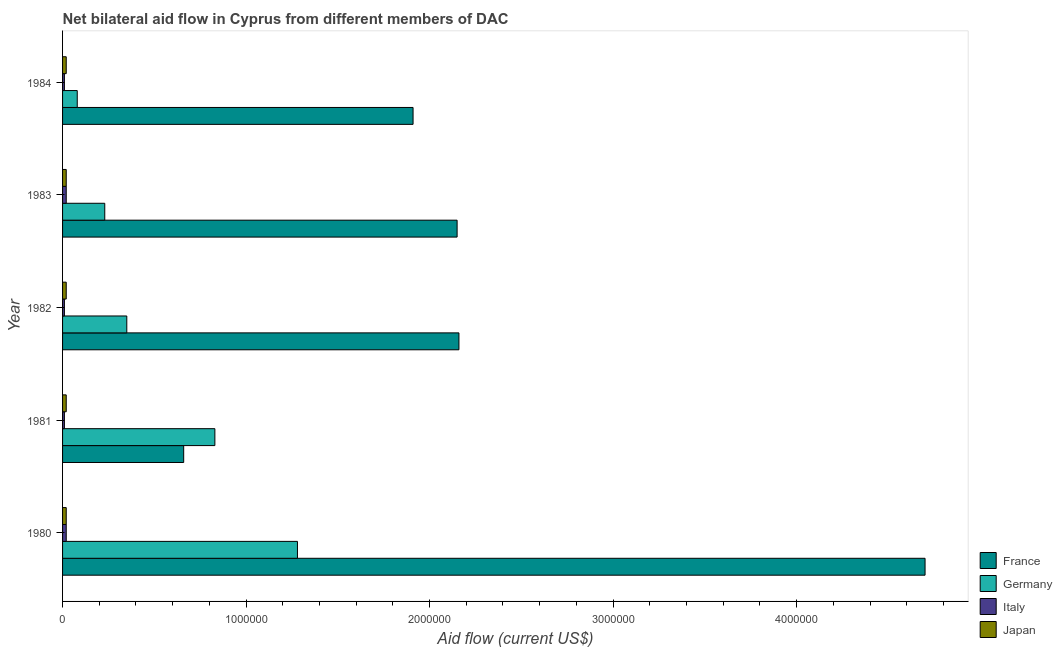Are the number of bars per tick equal to the number of legend labels?
Make the answer very short. Yes. Are the number of bars on each tick of the Y-axis equal?
Your answer should be compact. Yes. How many bars are there on the 3rd tick from the top?
Give a very brief answer. 4. How many bars are there on the 4th tick from the bottom?
Ensure brevity in your answer.  4. What is the label of the 5th group of bars from the top?
Offer a very short reply. 1980. In how many cases, is the number of bars for a given year not equal to the number of legend labels?
Give a very brief answer. 0. What is the amount of aid given by italy in 1982?
Ensure brevity in your answer.  10000. Across all years, what is the maximum amount of aid given by japan?
Make the answer very short. 2.00e+04. Across all years, what is the minimum amount of aid given by italy?
Provide a succinct answer. 10000. In which year was the amount of aid given by japan minimum?
Keep it short and to the point. 1980. What is the total amount of aid given by france in the graph?
Provide a short and direct response. 1.16e+07. What is the difference between the amount of aid given by germany in 1981 and that in 1983?
Offer a very short reply. 6.00e+05. What is the difference between the amount of aid given by france in 1981 and the amount of aid given by italy in 1983?
Provide a short and direct response. 6.40e+05. What is the average amount of aid given by italy per year?
Offer a terse response. 1.40e+04. In the year 1984, what is the difference between the amount of aid given by france and amount of aid given by japan?
Provide a short and direct response. 1.89e+06. In how many years, is the amount of aid given by germany greater than 4200000 US$?
Your response must be concise. 0. Is the amount of aid given by japan in 1981 less than that in 1983?
Make the answer very short. No. Is the difference between the amount of aid given by italy in 1980 and 1983 greater than the difference between the amount of aid given by japan in 1980 and 1983?
Offer a terse response. No. What is the difference between the highest and the second highest amount of aid given by france?
Make the answer very short. 2.54e+06. What is the difference between the highest and the lowest amount of aid given by japan?
Make the answer very short. 0. What does the 4th bar from the bottom in 1982 represents?
Your answer should be compact. Japan. Are all the bars in the graph horizontal?
Offer a terse response. Yes. What is the difference between two consecutive major ticks on the X-axis?
Provide a short and direct response. 1.00e+06. Does the graph contain any zero values?
Offer a very short reply. No. Does the graph contain grids?
Ensure brevity in your answer.  No. What is the title of the graph?
Your response must be concise. Net bilateral aid flow in Cyprus from different members of DAC. Does "Revenue mobilization" appear as one of the legend labels in the graph?
Offer a very short reply. No. What is the label or title of the X-axis?
Offer a terse response. Aid flow (current US$). What is the Aid flow (current US$) of France in 1980?
Your answer should be compact. 4.70e+06. What is the Aid flow (current US$) of Germany in 1980?
Give a very brief answer. 1.28e+06. What is the Aid flow (current US$) in Italy in 1980?
Keep it short and to the point. 2.00e+04. What is the Aid flow (current US$) of France in 1981?
Your answer should be compact. 6.60e+05. What is the Aid flow (current US$) in Germany in 1981?
Ensure brevity in your answer.  8.30e+05. What is the Aid flow (current US$) of Italy in 1981?
Give a very brief answer. 10000. What is the Aid flow (current US$) in France in 1982?
Your answer should be compact. 2.16e+06. What is the Aid flow (current US$) of Italy in 1982?
Ensure brevity in your answer.  10000. What is the Aid flow (current US$) of Japan in 1982?
Your response must be concise. 2.00e+04. What is the Aid flow (current US$) in France in 1983?
Offer a very short reply. 2.15e+06. What is the Aid flow (current US$) in Germany in 1983?
Make the answer very short. 2.30e+05. What is the Aid flow (current US$) in France in 1984?
Your response must be concise. 1.91e+06. Across all years, what is the maximum Aid flow (current US$) of France?
Your answer should be very brief. 4.70e+06. Across all years, what is the maximum Aid flow (current US$) of Germany?
Your answer should be compact. 1.28e+06. Across all years, what is the maximum Aid flow (current US$) of Italy?
Make the answer very short. 2.00e+04. Across all years, what is the minimum Aid flow (current US$) of France?
Your answer should be compact. 6.60e+05. Across all years, what is the minimum Aid flow (current US$) of Italy?
Provide a succinct answer. 10000. Across all years, what is the minimum Aid flow (current US$) of Japan?
Your answer should be compact. 2.00e+04. What is the total Aid flow (current US$) of France in the graph?
Your answer should be compact. 1.16e+07. What is the total Aid flow (current US$) of Germany in the graph?
Your answer should be very brief. 2.77e+06. What is the difference between the Aid flow (current US$) in France in 1980 and that in 1981?
Provide a short and direct response. 4.04e+06. What is the difference between the Aid flow (current US$) of Germany in 1980 and that in 1981?
Your response must be concise. 4.50e+05. What is the difference between the Aid flow (current US$) in France in 1980 and that in 1982?
Keep it short and to the point. 2.54e+06. What is the difference between the Aid flow (current US$) in Germany in 1980 and that in 1982?
Make the answer very short. 9.30e+05. What is the difference between the Aid flow (current US$) in Italy in 1980 and that in 1982?
Make the answer very short. 10000. What is the difference between the Aid flow (current US$) in France in 1980 and that in 1983?
Your answer should be very brief. 2.55e+06. What is the difference between the Aid flow (current US$) of Germany in 1980 and that in 1983?
Offer a terse response. 1.05e+06. What is the difference between the Aid flow (current US$) in Japan in 1980 and that in 1983?
Offer a very short reply. 0. What is the difference between the Aid flow (current US$) in France in 1980 and that in 1984?
Provide a succinct answer. 2.79e+06. What is the difference between the Aid flow (current US$) of Germany in 1980 and that in 1984?
Make the answer very short. 1.20e+06. What is the difference between the Aid flow (current US$) in Italy in 1980 and that in 1984?
Your answer should be compact. 10000. What is the difference between the Aid flow (current US$) of France in 1981 and that in 1982?
Your response must be concise. -1.50e+06. What is the difference between the Aid flow (current US$) in Germany in 1981 and that in 1982?
Provide a short and direct response. 4.80e+05. What is the difference between the Aid flow (current US$) of Italy in 1981 and that in 1982?
Provide a succinct answer. 0. What is the difference between the Aid flow (current US$) of France in 1981 and that in 1983?
Offer a terse response. -1.49e+06. What is the difference between the Aid flow (current US$) of Germany in 1981 and that in 1983?
Make the answer very short. 6.00e+05. What is the difference between the Aid flow (current US$) of Japan in 1981 and that in 1983?
Your answer should be compact. 0. What is the difference between the Aid flow (current US$) in France in 1981 and that in 1984?
Offer a very short reply. -1.25e+06. What is the difference between the Aid flow (current US$) of Germany in 1981 and that in 1984?
Provide a succinct answer. 7.50e+05. What is the difference between the Aid flow (current US$) in Japan in 1982 and that in 1983?
Your response must be concise. 0. What is the difference between the Aid flow (current US$) in France in 1982 and that in 1984?
Make the answer very short. 2.50e+05. What is the difference between the Aid flow (current US$) of Germany in 1983 and that in 1984?
Make the answer very short. 1.50e+05. What is the difference between the Aid flow (current US$) of France in 1980 and the Aid flow (current US$) of Germany in 1981?
Your answer should be very brief. 3.87e+06. What is the difference between the Aid flow (current US$) in France in 1980 and the Aid flow (current US$) in Italy in 1981?
Offer a terse response. 4.69e+06. What is the difference between the Aid flow (current US$) in France in 1980 and the Aid flow (current US$) in Japan in 1981?
Your response must be concise. 4.68e+06. What is the difference between the Aid flow (current US$) in Germany in 1980 and the Aid flow (current US$) in Italy in 1981?
Offer a terse response. 1.27e+06. What is the difference between the Aid flow (current US$) in Germany in 1980 and the Aid flow (current US$) in Japan in 1981?
Keep it short and to the point. 1.26e+06. What is the difference between the Aid flow (current US$) in France in 1980 and the Aid flow (current US$) in Germany in 1982?
Your response must be concise. 4.35e+06. What is the difference between the Aid flow (current US$) of France in 1980 and the Aid flow (current US$) of Italy in 1982?
Provide a succinct answer. 4.69e+06. What is the difference between the Aid flow (current US$) of France in 1980 and the Aid flow (current US$) of Japan in 1982?
Keep it short and to the point. 4.68e+06. What is the difference between the Aid flow (current US$) of Germany in 1980 and the Aid flow (current US$) of Italy in 1982?
Provide a succinct answer. 1.27e+06. What is the difference between the Aid flow (current US$) in Germany in 1980 and the Aid flow (current US$) in Japan in 1982?
Provide a short and direct response. 1.26e+06. What is the difference between the Aid flow (current US$) in France in 1980 and the Aid flow (current US$) in Germany in 1983?
Keep it short and to the point. 4.47e+06. What is the difference between the Aid flow (current US$) of France in 1980 and the Aid flow (current US$) of Italy in 1983?
Your answer should be compact. 4.68e+06. What is the difference between the Aid flow (current US$) in France in 1980 and the Aid flow (current US$) in Japan in 1983?
Keep it short and to the point. 4.68e+06. What is the difference between the Aid flow (current US$) in Germany in 1980 and the Aid flow (current US$) in Italy in 1983?
Ensure brevity in your answer.  1.26e+06. What is the difference between the Aid flow (current US$) in Germany in 1980 and the Aid flow (current US$) in Japan in 1983?
Ensure brevity in your answer.  1.26e+06. What is the difference between the Aid flow (current US$) in Italy in 1980 and the Aid flow (current US$) in Japan in 1983?
Provide a short and direct response. 0. What is the difference between the Aid flow (current US$) of France in 1980 and the Aid flow (current US$) of Germany in 1984?
Ensure brevity in your answer.  4.62e+06. What is the difference between the Aid flow (current US$) of France in 1980 and the Aid flow (current US$) of Italy in 1984?
Provide a short and direct response. 4.69e+06. What is the difference between the Aid flow (current US$) of France in 1980 and the Aid flow (current US$) of Japan in 1984?
Provide a short and direct response. 4.68e+06. What is the difference between the Aid flow (current US$) of Germany in 1980 and the Aid flow (current US$) of Italy in 1984?
Your answer should be compact. 1.27e+06. What is the difference between the Aid flow (current US$) in Germany in 1980 and the Aid flow (current US$) in Japan in 1984?
Make the answer very short. 1.26e+06. What is the difference between the Aid flow (current US$) in Italy in 1980 and the Aid flow (current US$) in Japan in 1984?
Make the answer very short. 0. What is the difference between the Aid flow (current US$) of France in 1981 and the Aid flow (current US$) of Germany in 1982?
Ensure brevity in your answer.  3.10e+05. What is the difference between the Aid flow (current US$) in France in 1981 and the Aid flow (current US$) in Italy in 1982?
Provide a short and direct response. 6.50e+05. What is the difference between the Aid flow (current US$) in France in 1981 and the Aid flow (current US$) in Japan in 1982?
Keep it short and to the point. 6.40e+05. What is the difference between the Aid flow (current US$) in Germany in 1981 and the Aid flow (current US$) in Italy in 1982?
Your answer should be compact. 8.20e+05. What is the difference between the Aid flow (current US$) of Germany in 1981 and the Aid flow (current US$) of Japan in 1982?
Offer a very short reply. 8.10e+05. What is the difference between the Aid flow (current US$) in Italy in 1981 and the Aid flow (current US$) in Japan in 1982?
Make the answer very short. -10000. What is the difference between the Aid flow (current US$) in France in 1981 and the Aid flow (current US$) in Germany in 1983?
Your answer should be very brief. 4.30e+05. What is the difference between the Aid flow (current US$) of France in 1981 and the Aid flow (current US$) of Italy in 1983?
Your answer should be very brief. 6.40e+05. What is the difference between the Aid flow (current US$) of France in 1981 and the Aid flow (current US$) of Japan in 1983?
Give a very brief answer. 6.40e+05. What is the difference between the Aid flow (current US$) of Germany in 1981 and the Aid flow (current US$) of Italy in 1983?
Your response must be concise. 8.10e+05. What is the difference between the Aid flow (current US$) in Germany in 1981 and the Aid flow (current US$) in Japan in 1983?
Give a very brief answer. 8.10e+05. What is the difference between the Aid flow (current US$) in Italy in 1981 and the Aid flow (current US$) in Japan in 1983?
Give a very brief answer. -10000. What is the difference between the Aid flow (current US$) of France in 1981 and the Aid flow (current US$) of Germany in 1984?
Ensure brevity in your answer.  5.80e+05. What is the difference between the Aid flow (current US$) in France in 1981 and the Aid flow (current US$) in Italy in 1984?
Provide a short and direct response. 6.50e+05. What is the difference between the Aid flow (current US$) of France in 1981 and the Aid flow (current US$) of Japan in 1984?
Ensure brevity in your answer.  6.40e+05. What is the difference between the Aid flow (current US$) in Germany in 1981 and the Aid flow (current US$) in Italy in 1984?
Make the answer very short. 8.20e+05. What is the difference between the Aid flow (current US$) in Germany in 1981 and the Aid flow (current US$) in Japan in 1984?
Keep it short and to the point. 8.10e+05. What is the difference between the Aid flow (current US$) of Italy in 1981 and the Aid flow (current US$) of Japan in 1984?
Your response must be concise. -10000. What is the difference between the Aid flow (current US$) of France in 1982 and the Aid flow (current US$) of Germany in 1983?
Your answer should be very brief. 1.93e+06. What is the difference between the Aid flow (current US$) in France in 1982 and the Aid flow (current US$) in Italy in 1983?
Your answer should be very brief. 2.14e+06. What is the difference between the Aid flow (current US$) of France in 1982 and the Aid flow (current US$) of Japan in 1983?
Your response must be concise. 2.14e+06. What is the difference between the Aid flow (current US$) in Germany in 1982 and the Aid flow (current US$) in Italy in 1983?
Provide a short and direct response. 3.30e+05. What is the difference between the Aid flow (current US$) of Germany in 1982 and the Aid flow (current US$) of Japan in 1983?
Offer a very short reply. 3.30e+05. What is the difference between the Aid flow (current US$) of Italy in 1982 and the Aid flow (current US$) of Japan in 1983?
Ensure brevity in your answer.  -10000. What is the difference between the Aid flow (current US$) of France in 1982 and the Aid flow (current US$) of Germany in 1984?
Keep it short and to the point. 2.08e+06. What is the difference between the Aid flow (current US$) in France in 1982 and the Aid flow (current US$) in Italy in 1984?
Keep it short and to the point. 2.15e+06. What is the difference between the Aid flow (current US$) in France in 1982 and the Aid flow (current US$) in Japan in 1984?
Your response must be concise. 2.14e+06. What is the difference between the Aid flow (current US$) of Germany in 1982 and the Aid flow (current US$) of Italy in 1984?
Ensure brevity in your answer.  3.40e+05. What is the difference between the Aid flow (current US$) in France in 1983 and the Aid flow (current US$) in Germany in 1984?
Your answer should be compact. 2.07e+06. What is the difference between the Aid flow (current US$) of France in 1983 and the Aid flow (current US$) of Italy in 1984?
Offer a terse response. 2.14e+06. What is the difference between the Aid flow (current US$) of France in 1983 and the Aid flow (current US$) of Japan in 1984?
Provide a succinct answer. 2.13e+06. What is the difference between the Aid flow (current US$) in Germany in 1983 and the Aid flow (current US$) in Italy in 1984?
Keep it short and to the point. 2.20e+05. What is the average Aid flow (current US$) of France per year?
Your response must be concise. 2.32e+06. What is the average Aid flow (current US$) of Germany per year?
Keep it short and to the point. 5.54e+05. What is the average Aid flow (current US$) of Italy per year?
Keep it short and to the point. 1.40e+04. In the year 1980, what is the difference between the Aid flow (current US$) of France and Aid flow (current US$) of Germany?
Make the answer very short. 3.42e+06. In the year 1980, what is the difference between the Aid flow (current US$) in France and Aid flow (current US$) in Italy?
Ensure brevity in your answer.  4.68e+06. In the year 1980, what is the difference between the Aid flow (current US$) of France and Aid flow (current US$) of Japan?
Give a very brief answer. 4.68e+06. In the year 1980, what is the difference between the Aid flow (current US$) of Germany and Aid flow (current US$) of Italy?
Offer a very short reply. 1.26e+06. In the year 1980, what is the difference between the Aid flow (current US$) in Germany and Aid flow (current US$) in Japan?
Provide a succinct answer. 1.26e+06. In the year 1981, what is the difference between the Aid flow (current US$) in France and Aid flow (current US$) in Germany?
Provide a succinct answer. -1.70e+05. In the year 1981, what is the difference between the Aid flow (current US$) of France and Aid flow (current US$) of Italy?
Provide a succinct answer. 6.50e+05. In the year 1981, what is the difference between the Aid flow (current US$) of France and Aid flow (current US$) of Japan?
Keep it short and to the point. 6.40e+05. In the year 1981, what is the difference between the Aid flow (current US$) in Germany and Aid flow (current US$) in Italy?
Your answer should be compact. 8.20e+05. In the year 1981, what is the difference between the Aid flow (current US$) of Germany and Aid flow (current US$) of Japan?
Offer a terse response. 8.10e+05. In the year 1981, what is the difference between the Aid flow (current US$) of Italy and Aid flow (current US$) of Japan?
Provide a short and direct response. -10000. In the year 1982, what is the difference between the Aid flow (current US$) in France and Aid flow (current US$) in Germany?
Ensure brevity in your answer.  1.81e+06. In the year 1982, what is the difference between the Aid flow (current US$) of France and Aid flow (current US$) of Italy?
Provide a short and direct response. 2.15e+06. In the year 1982, what is the difference between the Aid flow (current US$) in France and Aid flow (current US$) in Japan?
Keep it short and to the point. 2.14e+06. In the year 1982, what is the difference between the Aid flow (current US$) of Germany and Aid flow (current US$) of Italy?
Ensure brevity in your answer.  3.40e+05. In the year 1983, what is the difference between the Aid flow (current US$) of France and Aid flow (current US$) of Germany?
Your answer should be very brief. 1.92e+06. In the year 1983, what is the difference between the Aid flow (current US$) in France and Aid flow (current US$) in Italy?
Make the answer very short. 2.13e+06. In the year 1983, what is the difference between the Aid flow (current US$) of France and Aid flow (current US$) of Japan?
Provide a succinct answer. 2.13e+06. In the year 1983, what is the difference between the Aid flow (current US$) in Germany and Aid flow (current US$) in Italy?
Your response must be concise. 2.10e+05. In the year 1984, what is the difference between the Aid flow (current US$) in France and Aid flow (current US$) in Germany?
Your answer should be compact. 1.83e+06. In the year 1984, what is the difference between the Aid flow (current US$) in France and Aid flow (current US$) in Italy?
Make the answer very short. 1.90e+06. In the year 1984, what is the difference between the Aid flow (current US$) of France and Aid flow (current US$) of Japan?
Your answer should be compact. 1.89e+06. In the year 1984, what is the difference between the Aid flow (current US$) of Germany and Aid flow (current US$) of Japan?
Keep it short and to the point. 6.00e+04. In the year 1984, what is the difference between the Aid flow (current US$) in Italy and Aid flow (current US$) in Japan?
Offer a terse response. -10000. What is the ratio of the Aid flow (current US$) in France in 1980 to that in 1981?
Offer a very short reply. 7.12. What is the ratio of the Aid flow (current US$) in Germany in 1980 to that in 1981?
Provide a short and direct response. 1.54. What is the ratio of the Aid flow (current US$) in Italy in 1980 to that in 1981?
Your answer should be compact. 2. What is the ratio of the Aid flow (current US$) in France in 1980 to that in 1982?
Your answer should be very brief. 2.18. What is the ratio of the Aid flow (current US$) in Germany in 1980 to that in 1982?
Ensure brevity in your answer.  3.66. What is the ratio of the Aid flow (current US$) of France in 1980 to that in 1983?
Keep it short and to the point. 2.19. What is the ratio of the Aid flow (current US$) in Germany in 1980 to that in 1983?
Provide a succinct answer. 5.57. What is the ratio of the Aid flow (current US$) of Japan in 1980 to that in 1983?
Ensure brevity in your answer.  1. What is the ratio of the Aid flow (current US$) in France in 1980 to that in 1984?
Ensure brevity in your answer.  2.46. What is the ratio of the Aid flow (current US$) in France in 1981 to that in 1982?
Offer a very short reply. 0.31. What is the ratio of the Aid flow (current US$) in Germany in 1981 to that in 1982?
Your answer should be very brief. 2.37. What is the ratio of the Aid flow (current US$) of Japan in 1981 to that in 1982?
Give a very brief answer. 1. What is the ratio of the Aid flow (current US$) of France in 1981 to that in 1983?
Give a very brief answer. 0.31. What is the ratio of the Aid flow (current US$) in Germany in 1981 to that in 1983?
Ensure brevity in your answer.  3.61. What is the ratio of the Aid flow (current US$) of Italy in 1981 to that in 1983?
Offer a terse response. 0.5. What is the ratio of the Aid flow (current US$) of Japan in 1981 to that in 1983?
Keep it short and to the point. 1. What is the ratio of the Aid flow (current US$) in France in 1981 to that in 1984?
Offer a very short reply. 0.35. What is the ratio of the Aid flow (current US$) in Germany in 1981 to that in 1984?
Your answer should be very brief. 10.38. What is the ratio of the Aid flow (current US$) in Japan in 1981 to that in 1984?
Your answer should be very brief. 1. What is the ratio of the Aid flow (current US$) in France in 1982 to that in 1983?
Your response must be concise. 1. What is the ratio of the Aid flow (current US$) of Germany in 1982 to that in 1983?
Make the answer very short. 1.52. What is the ratio of the Aid flow (current US$) of Italy in 1982 to that in 1983?
Your answer should be compact. 0.5. What is the ratio of the Aid flow (current US$) of France in 1982 to that in 1984?
Your answer should be compact. 1.13. What is the ratio of the Aid flow (current US$) of Germany in 1982 to that in 1984?
Ensure brevity in your answer.  4.38. What is the ratio of the Aid flow (current US$) of Italy in 1982 to that in 1984?
Give a very brief answer. 1. What is the ratio of the Aid flow (current US$) of France in 1983 to that in 1984?
Your response must be concise. 1.13. What is the ratio of the Aid flow (current US$) of Germany in 1983 to that in 1984?
Keep it short and to the point. 2.88. What is the difference between the highest and the second highest Aid flow (current US$) in France?
Keep it short and to the point. 2.54e+06. What is the difference between the highest and the second highest Aid flow (current US$) of Germany?
Your answer should be compact. 4.50e+05. What is the difference between the highest and the second highest Aid flow (current US$) of Italy?
Your response must be concise. 0. What is the difference between the highest and the second highest Aid flow (current US$) in Japan?
Your response must be concise. 0. What is the difference between the highest and the lowest Aid flow (current US$) in France?
Offer a very short reply. 4.04e+06. What is the difference between the highest and the lowest Aid flow (current US$) of Germany?
Keep it short and to the point. 1.20e+06. What is the difference between the highest and the lowest Aid flow (current US$) in Japan?
Make the answer very short. 0. 